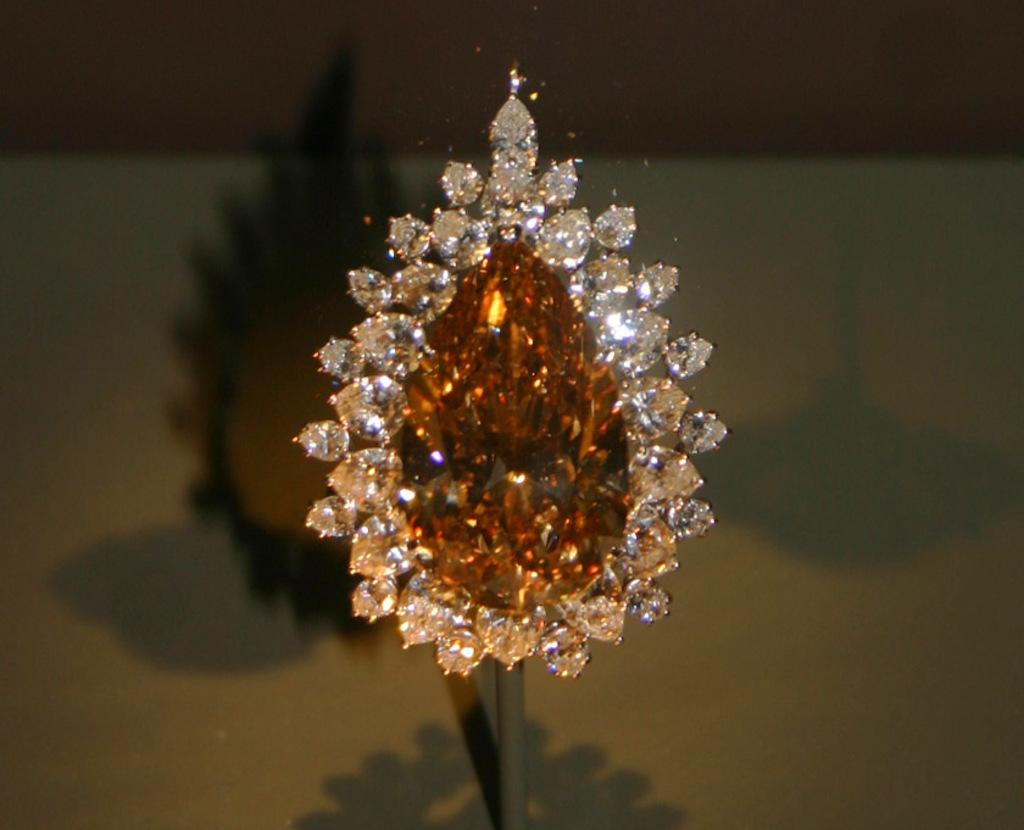What can be seen in the picture? There is an ornament in the picture. Can you describe any additional details about the ornament? The shadow of the ornament is visible in the picture. What type of quince is being used as a decoration in the picture? There is no quince present in the picture; the image features an ornament and its shadow. 